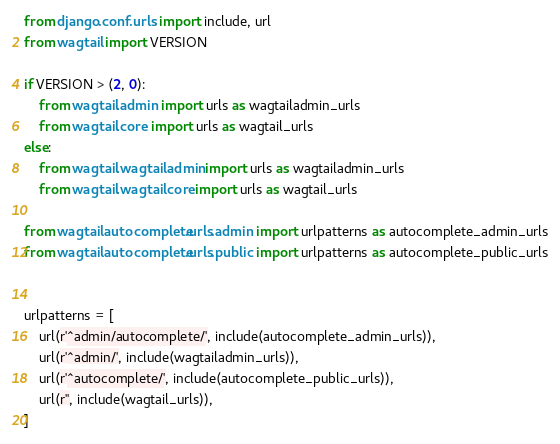<code> <loc_0><loc_0><loc_500><loc_500><_Python_>from django.conf.urls import include, url
from wagtail import VERSION

if VERSION > (2, 0):
    from wagtail.admin import urls as wagtailadmin_urls
    from wagtail.core import urls as wagtail_urls
else:
    from wagtail.wagtailadmin import urls as wagtailadmin_urls
    from wagtail.wagtailcore import urls as wagtail_urls

from wagtailautocomplete.urls.admin import urlpatterns as autocomplete_admin_urls
from wagtailautocomplete.urls.public import urlpatterns as autocomplete_public_urls


urlpatterns = [
    url(r'^admin/autocomplete/', include(autocomplete_admin_urls)),
    url(r'^admin/', include(wagtailadmin_urls)),
    url(r'^autocomplete/', include(autocomplete_public_urls)),
    url(r'', include(wagtail_urls)),
]
</code> 